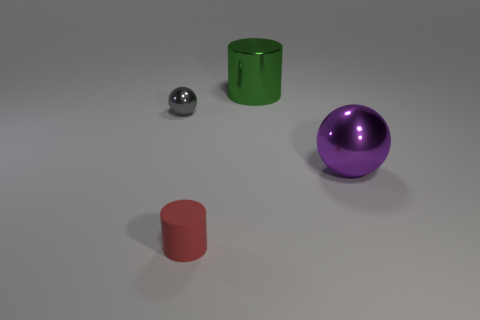Subtract all red cylinders. How many cylinders are left? 1 Add 2 big purple shiny blocks. How many objects exist? 6 Subtract 1 cylinders. How many cylinders are left? 1 Add 4 gray rubber things. How many gray rubber things exist? 4 Subtract 0 brown cylinders. How many objects are left? 4 Subtract all yellow cylinders. Subtract all purple balls. How many cylinders are left? 2 Subtract all purple rubber spheres. Subtract all large green things. How many objects are left? 3 Add 1 shiny spheres. How many shiny spheres are left? 3 